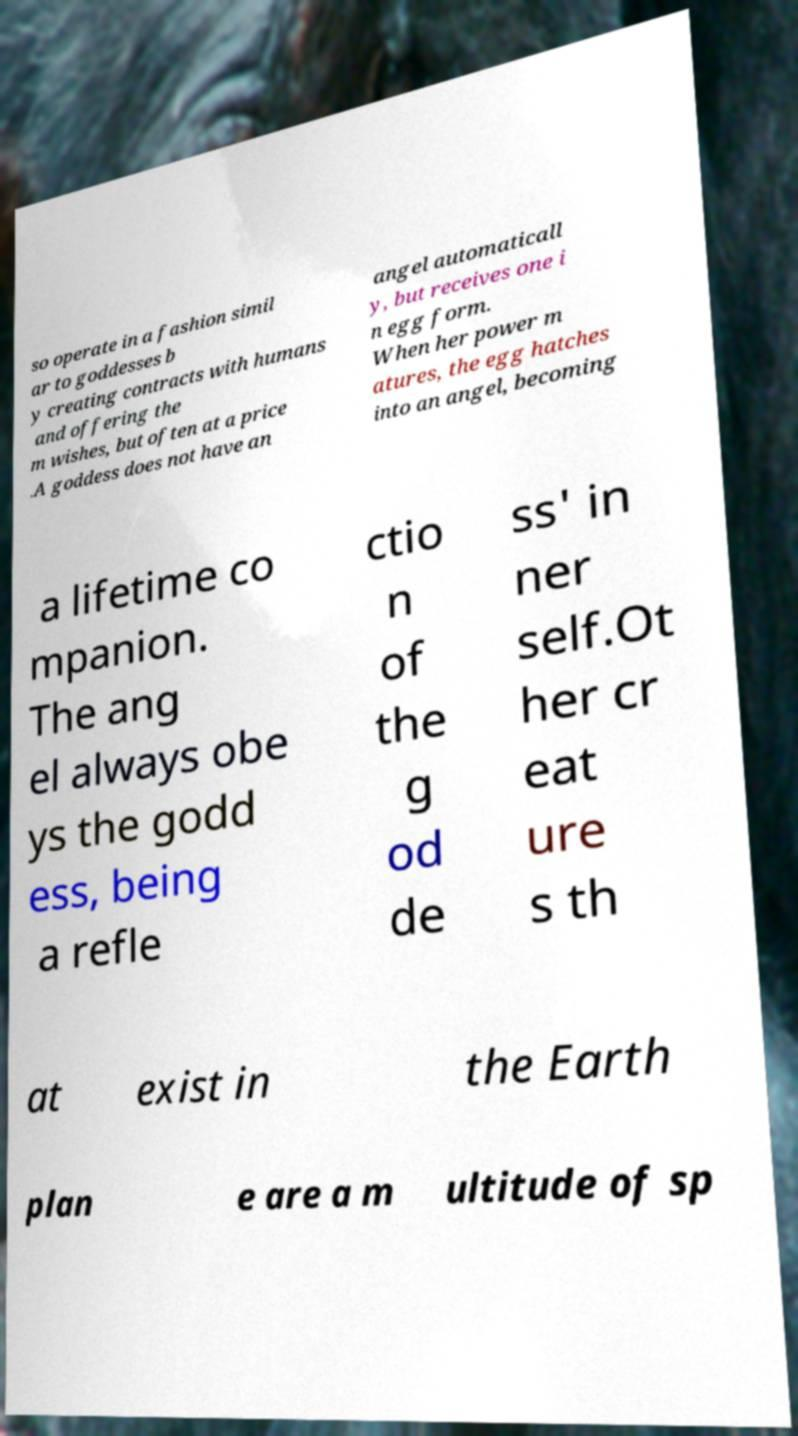Can you read and provide the text displayed in the image?This photo seems to have some interesting text. Can you extract and type it out for me? so operate in a fashion simil ar to goddesses b y creating contracts with humans and offering the m wishes, but often at a price .A goddess does not have an angel automaticall y, but receives one i n egg form. When her power m atures, the egg hatches into an angel, becoming a lifetime co mpanion. The ang el always obe ys the godd ess, being a refle ctio n of the g od de ss' in ner self.Ot her cr eat ure s th at exist in the Earth plan e are a m ultitude of sp 